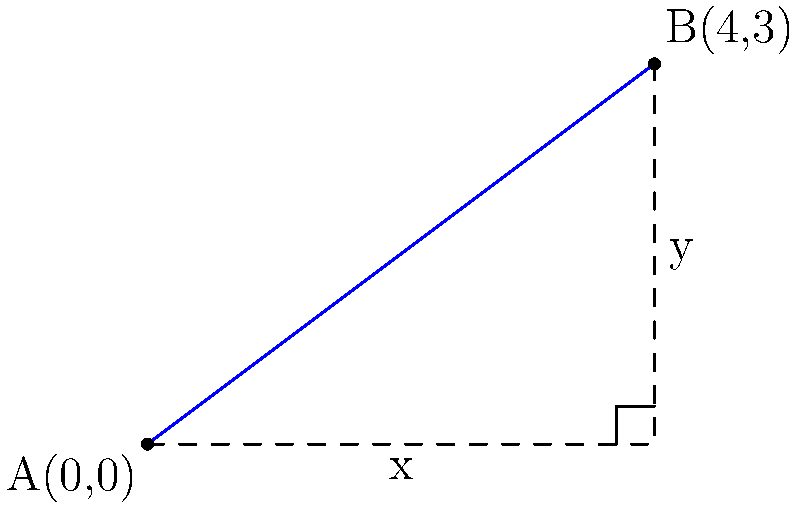In the development of the distance formula, how does the geometric representation of two points on a coordinate plane relate to Pythagoras' theorem? Explain the connection using the given diagram, where point A is at (0,0) and point B is at (4,3). 1. The distance formula is derived from Pythagoras' theorem. Let's examine how:

2. In the diagram, we have two points: A(0,0) and B(4,3).

3. The horizontal distance between A and B is the difference in x-coordinates: 4 - 0 = 4.

4. The vertical distance is the difference in y-coordinates: 3 - 0 = 3.

5. These distances form a right triangle, where:
   - The horizontal distance is one leg (4 units)
   - The vertical distance is the other leg (3 units)
   - The line segment AB is the hypotenuse

6. Pythagoras' theorem states that in a right triangle: $a^2 + b^2 = c^2$, where c is the hypotenuse.

7. Applying this to our triangle:
   $4^2 + 3^2 = c^2$
   $16 + 9 = c^2$
   $25 = c^2$
   $c = 5$

8. The distance formula generalizes this concept:
   For two points $(x_1, y_1)$ and $(x_2, y_2)$:
   Distance = $\sqrt{(x_2 - x_1)^2 + (y_2 - y_1)^2}$

9. This is equivalent to Pythagoras' theorem, where:
   - $(x_2 - x_1)$ is the horizontal leg
   - $(y_2 - y_1)$ is the vertical leg
   - The square root of their sum of squares is the hypotenuse (distance)

10. In our example:
    Distance = $\sqrt{(4 - 0)^2 + (3 - 0)^2} = \sqrt{16 + 9} = \sqrt{25} = 5$

Thus, the distance formula is a direct application of Pythagoras' theorem to find the length of the hypotenuse (straight-line distance) between two points on a coordinate plane.
Answer: The distance formula is a generalization of Pythagoras' theorem applied to coordinate geometry, calculating the straight-line distance between two points as the hypotenuse of a right triangle formed by their coordinate differences. 